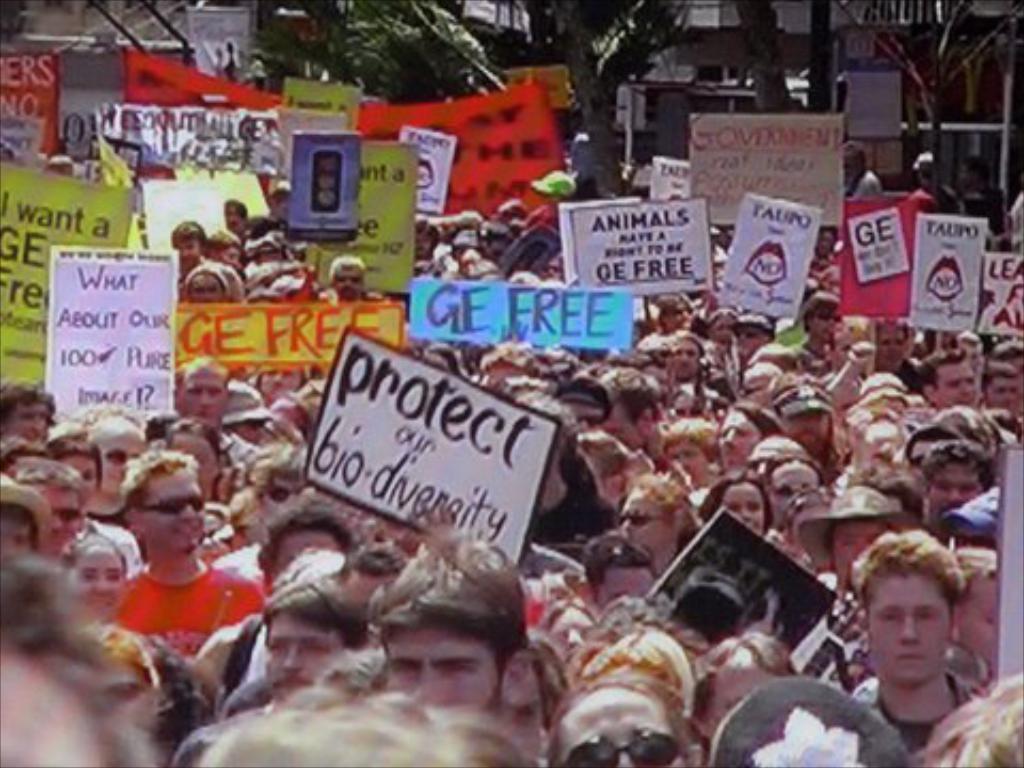In one or two sentences, can you explain what this image depicts? In this image there are group of persons, there are boards, there is text on the boards, there are trees truncated towards the top of the image, there are boards truncated towards the left of the image, there are boards truncated towards the right of the image, there are persons truncated towards the left of the image, there are persons truncated towards the right of the image, there are persons truncated towards the bottom of the image. 